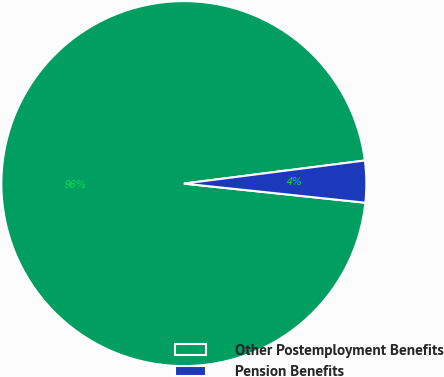Convert chart. <chart><loc_0><loc_0><loc_500><loc_500><pie_chart><fcel>Other Postemployment Benefits<fcel>Pension Benefits<nl><fcel>96.31%<fcel>3.69%<nl></chart> 